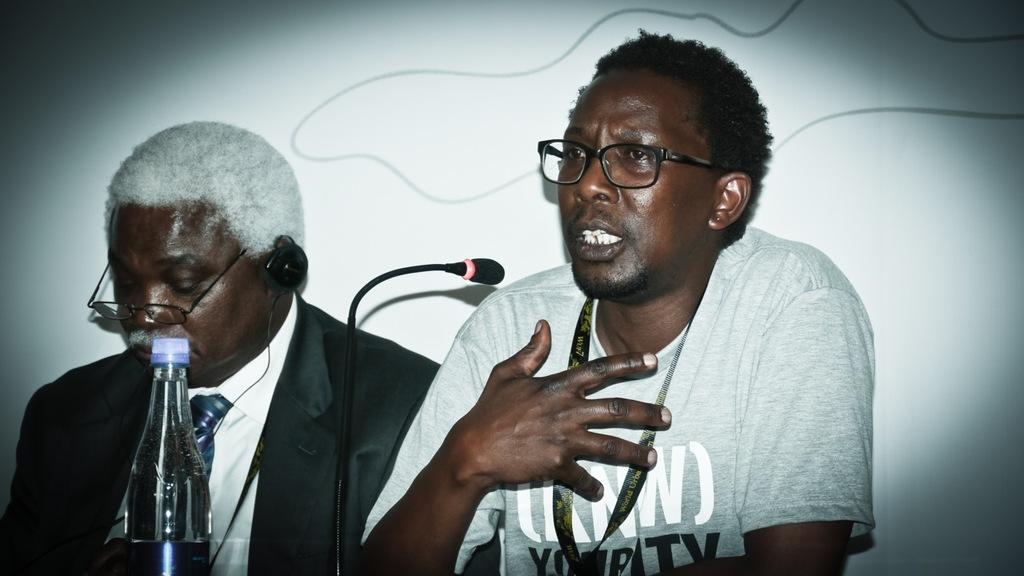How many people are in the image? There are two men in the image. What is one of the men doing in the image? One of the men is talking on a microphone. What object can be seen in the image besides the men and the microphone? There is a bottle in the image. What can be seen in the background of the image? There is a wall in the background of the image. How many chairs are visible in the image? There are no chairs visible in the image. What is the distance between the two men in the image? The distance between the two men cannot be determined from the image alone, as there is no reference point for measurement. 